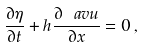Convert formula to latex. <formula><loc_0><loc_0><loc_500><loc_500>\frac { \partial \eta } { \partial t } + h \frac { \partial \ a v u } { \partial x } = 0 \, ,</formula> 